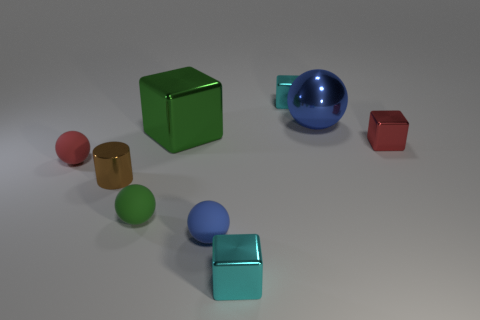Subtract all red balls. Subtract all yellow cubes. How many balls are left? 3 Subtract all cylinders. How many objects are left? 8 Add 7 small cyan metal cubes. How many small cyan metal cubes exist? 9 Subtract 0 gray spheres. How many objects are left? 9 Subtract all blue metal cubes. Subtract all tiny red things. How many objects are left? 7 Add 2 big blue metallic things. How many big blue metallic things are left? 3 